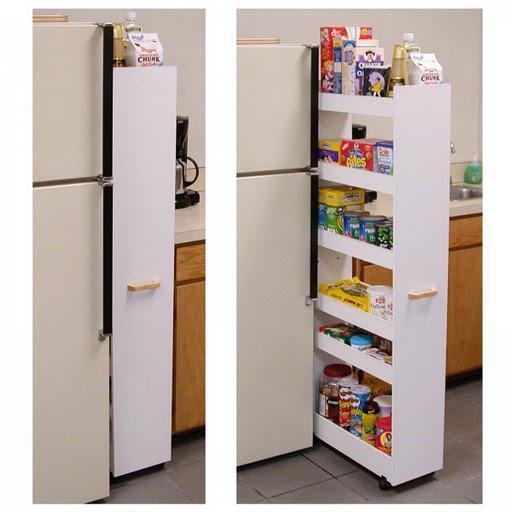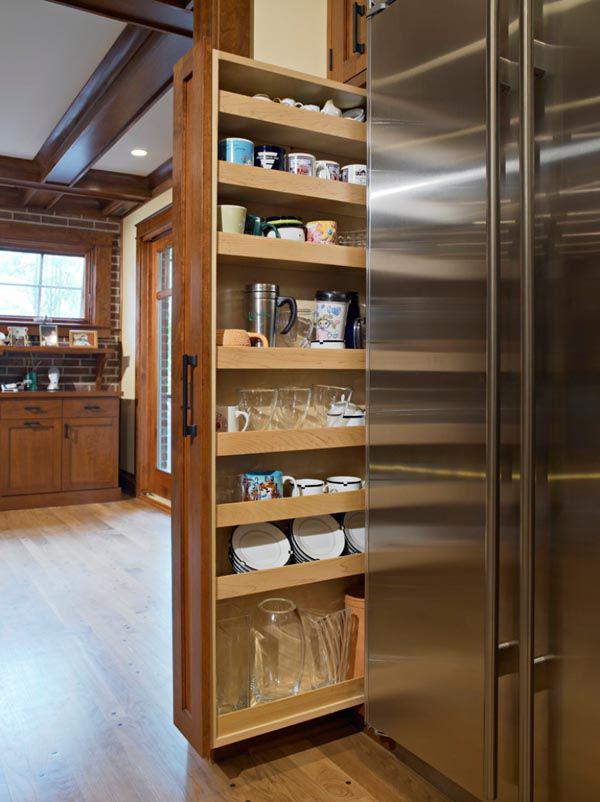The first image is the image on the left, the second image is the image on the right. For the images shown, is this caption "The right image shows a narrow filled pantry with a handle pulled out from behind a stainless steel refrigerator and in front of a doorway." true? Answer yes or no. Yes. 